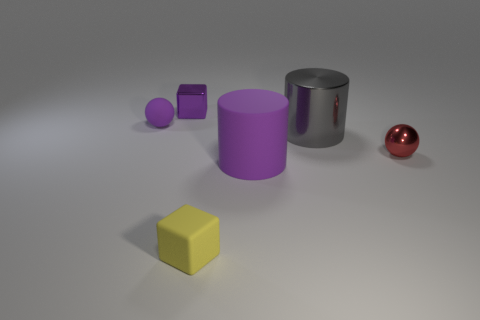Subtract 1 cylinders. How many cylinders are left? 1 Add 4 small blue shiny things. How many objects exist? 10 Subtract all blocks. How many objects are left? 4 Subtract 0 brown cylinders. How many objects are left? 6 Subtract all red cubes. Subtract all yellow spheres. How many cubes are left? 2 Subtract all cylinders. Subtract all small purple things. How many objects are left? 2 Add 1 big gray cylinders. How many big gray cylinders are left? 2 Add 6 big gray shiny cylinders. How many big gray shiny cylinders exist? 7 